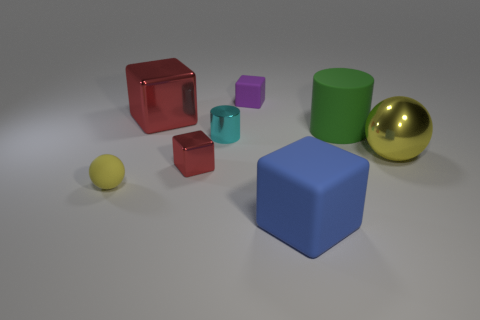What size is the ball that is on the left side of the yellow ball to the right of the small cyan metallic thing?
Your response must be concise. Small. How many large things are either spheres or purple matte things?
Offer a very short reply. 1. What number of other objects are there of the same color as the tiny matte sphere?
Keep it short and to the point. 1. There is a purple object behind the tiny shiny block; is its size the same as the yellow thing that is left of the cyan thing?
Offer a very short reply. Yes. Do the small purple cube and the yellow thing on the right side of the yellow matte object have the same material?
Make the answer very short. No. Is the number of tiny metallic blocks on the left side of the large green cylinder greater than the number of large cubes that are on the right side of the blue object?
Your answer should be very brief. Yes. There is a small rubber object that is behind the sphere that is to the right of the large blue block; what is its color?
Give a very brief answer. Purple. What number of balls are either large green objects or big yellow metallic objects?
Offer a terse response. 1. How many big objects are on the left side of the large green rubber cylinder and right of the tiny red cube?
Provide a succinct answer. 1. What is the color of the thing to the left of the big red thing?
Make the answer very short. Yellow. 